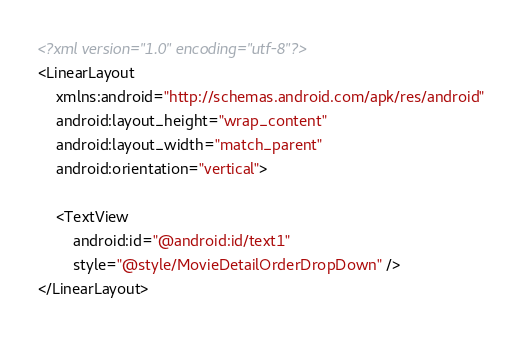<code> <loc_0><loc_0><loc_500><loc_500><_XML_><?xml version="1.0" encoding="utf-8"?>
<LinearLayout
    xmlns:android="http://schemas.android.com/apk/res/android"
    android:layout_height="wrap_content"
    android:layout_width="match_parent"
    android:orientation="vertical">

    <TextView
        android:id="@android:id/text1"
        style="@style/MovieDetailOrderDropDown" />
</LinearLayout>
</code> 